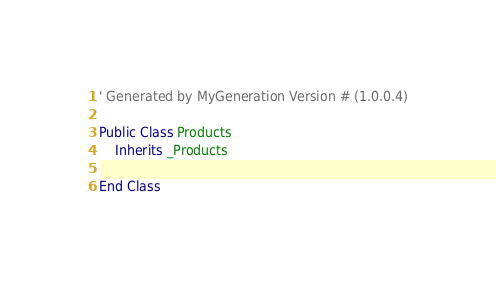<code> <loc_0><loc_0><loc_500><loc_500><_VisualBasic_>
' Generated by MyGeneration Version # (1.0.0.4)

Public Class Products
    Inherits _Products

End Class
</code> 